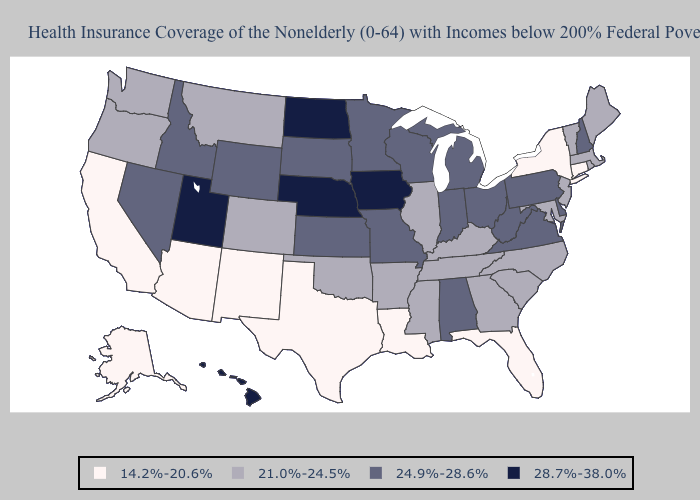Which states hav the highest value in the South?
Keep it brief. Alabama, Delaware, Virginia, West Virginia. Among the states that border New York , which have the highest value?
Be succinct. Pennsylvania. Name the states that have a value in the range 21.0%-24.5%?
Concise answer only. Arkansas, Colorado, Georgia, Illinois, Kentucky, Maine, Maryland, Massachusetts, Mississippi, Montana, New Jersey, North Carolina, Oklahoma, Oregon, Rhode Island, South Carolina, Tennessee, Vermont, Washington. What is the highest value in the West ?
Concise answer only. 28.7%-38.0%. Does Kentucky have the same value as Arkansas?
Concise answer only. Yes. Name the states that have a value in the range 24.9%-28.6%?
Quick response, please. Alabama, Delaware, Idaho, Indiana, Kansas, Michigan, Minnesota, Missouri, Nevada, New Hampshire, Ohio, Pennsylvania, South Dakota, Virginia, West Virginia, Wisconsin, Wyoming. Name the states that have a value in the range 14.2%-20.6%?
Keep it brief. Alaska, Arizona, California, Connecticut, Florida, Louisiana, New Mexico, New York, Texas. How many symbols are there in the legend?
Concise answer only. 4. What is the lowest value in the USA?
Concise answer only. 14.2%-20.6%. Does North Dakota have the highest value in the USA?
Short answer required. Yes. Among the states that border Florida , does Alabama have the lowest value?
Answer briefly. No. What is the value of Vermont?
Short answer required. 21.0%-24.5%. Name the states that have a value in the range 28.7%-38.0%?
Answer briefly. Hawaii, Iowa, Nebraska, North Dakota, Utah. Does the map have missing data?
Short answer required. No. Does the first symbol in the legend represent the smallest category?
Be succinct. Yes. 